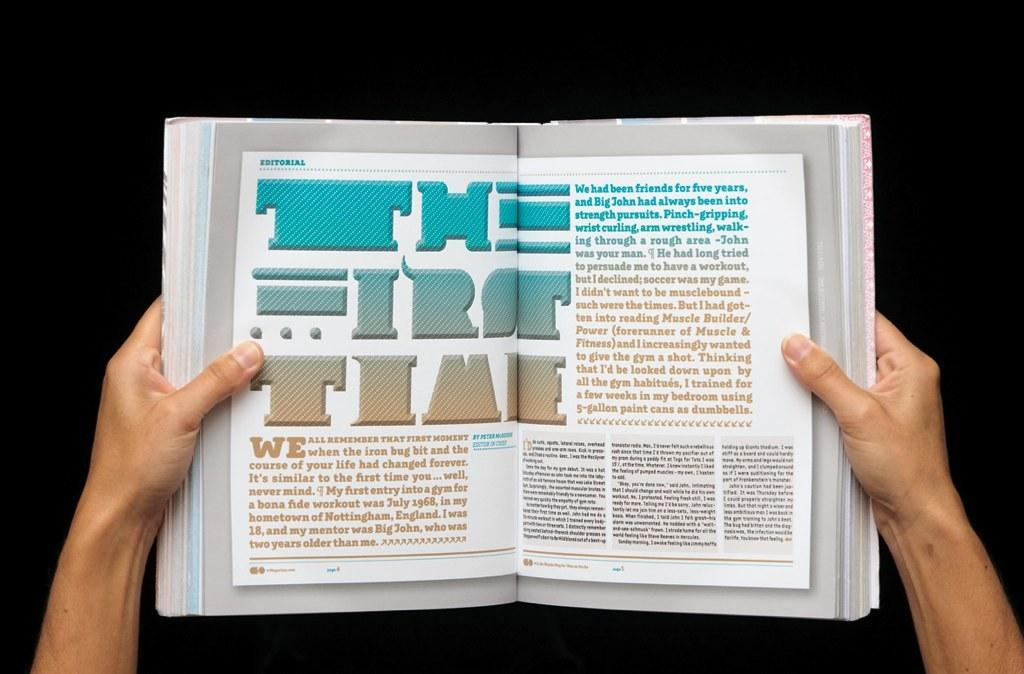<image>
Relay a brief, clear account of the picture shown. a book that is open to a page with the word time on it 